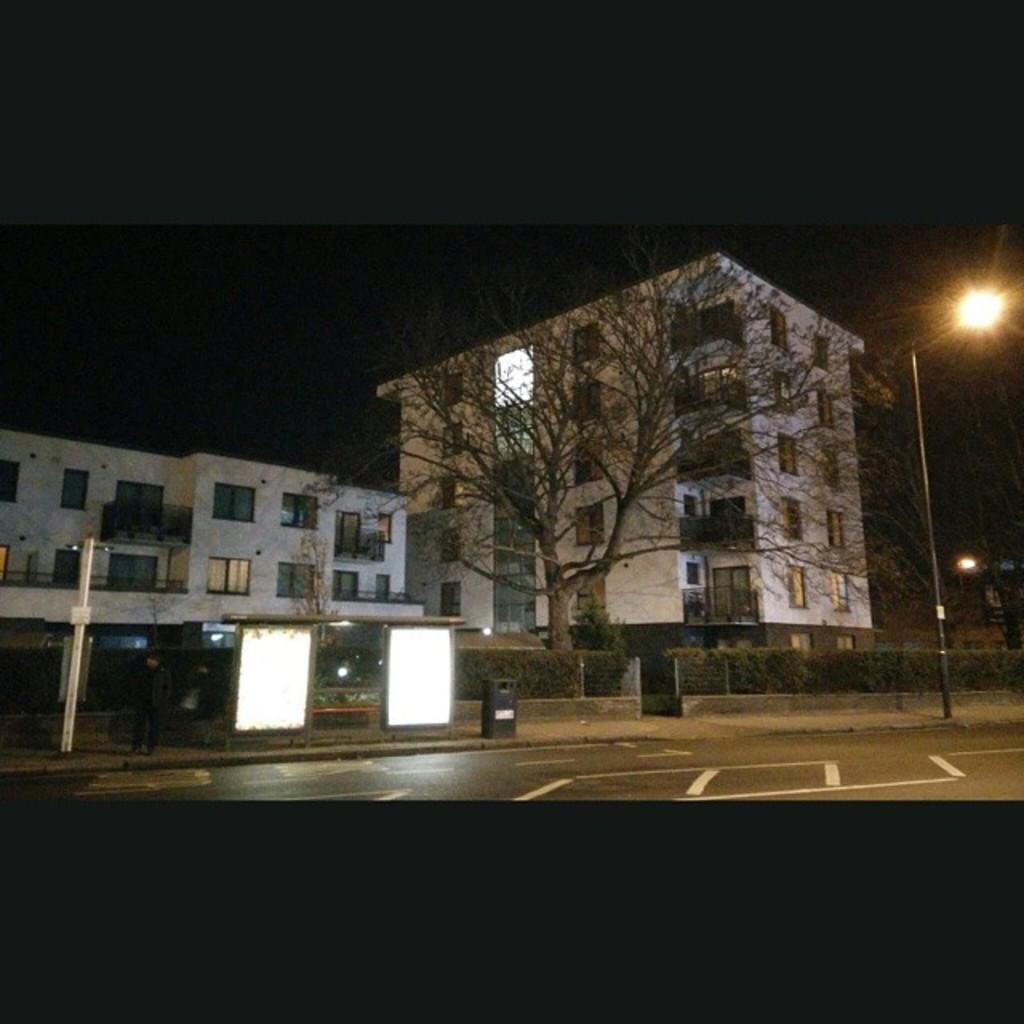In one or two sentences, can you explain what this image depicts? In this image there are buildings, trees, plants, boards, poles, lights, person, dark sky, road and objects. 